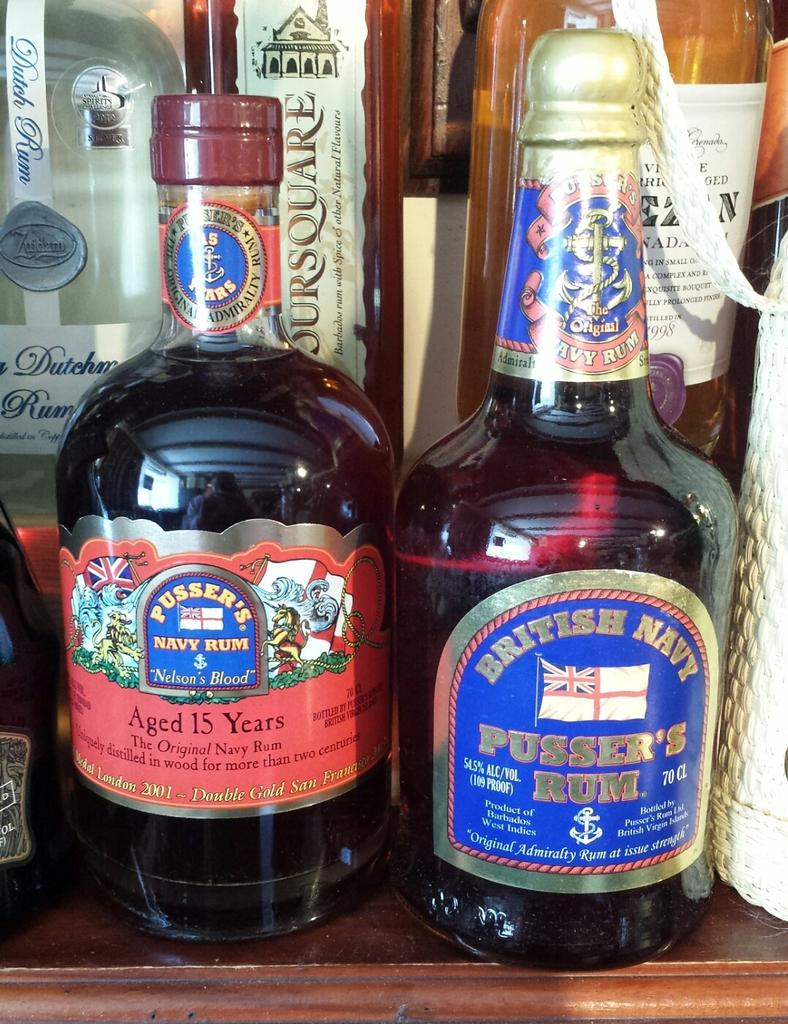<image>
Present a compact description of the photo's key features. Two rum bottles sit nestled in other alcohols on a wooden surface 